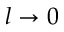<formula> <loc_0><loc_0><loc_500><loc_500>l \to 0</formula> 